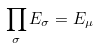Convert formula to latex. <formula><loc_0><loc_0><loc_500><loc_500>\prod _ { \sigma } E _ { \sigma } = E _ { \mu }</formula> 